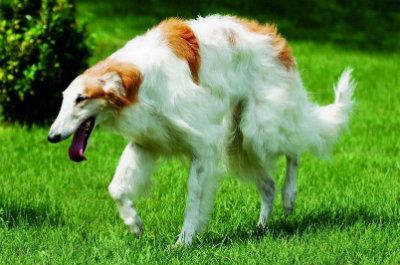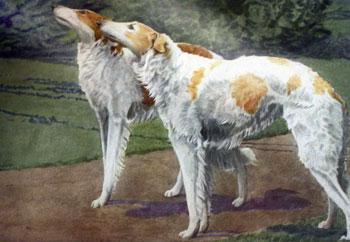The first image is the image on the left, the second image is the image on the right. Analyze the images presented: Is the assertion "One images has two dogs fighting each other." valid? Answer yes or no. No. The first image is the image on the left, the second image is the image on the right. Considering the images on both sides, is "There is one image of two dogs that are actively playing together outside." valid? Answer yes or no. No. 